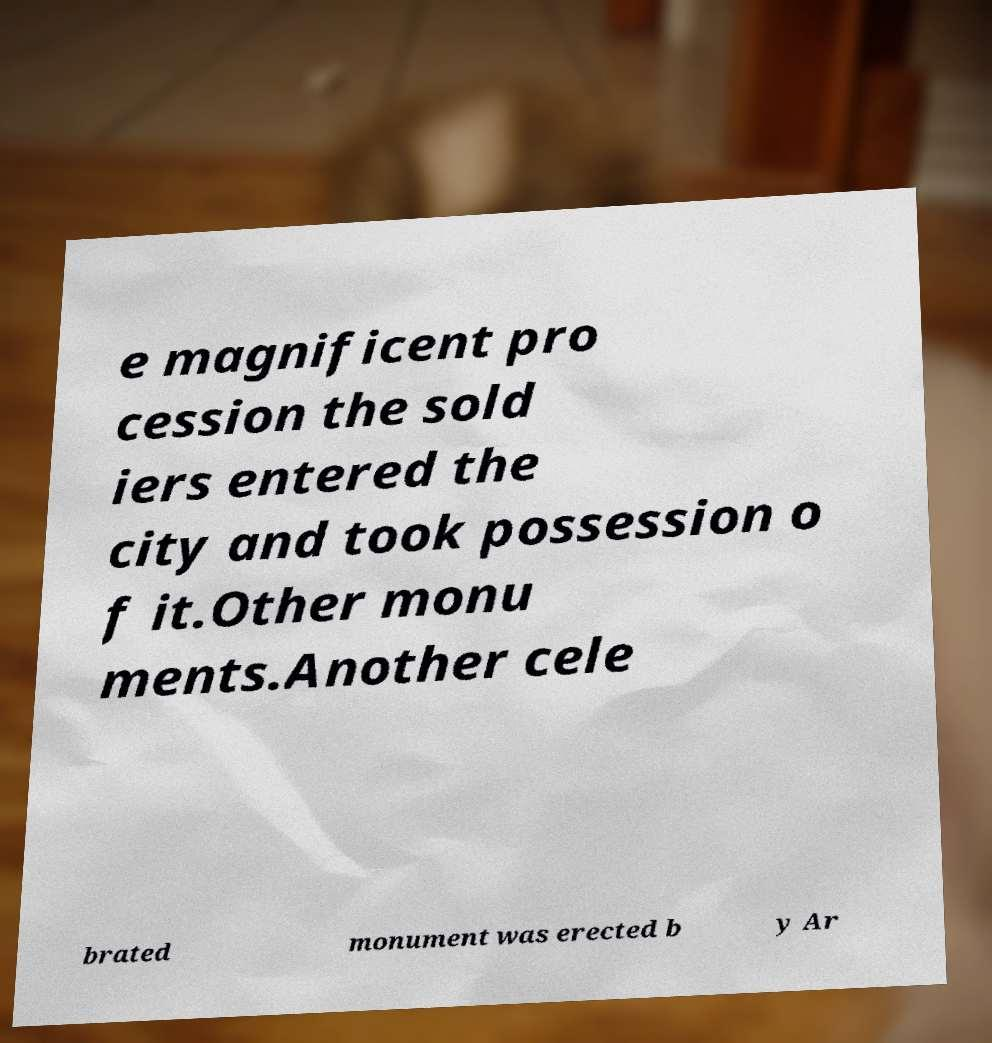For documentation purposes, I need the text within this image transcribed. Could you provide that? e magnificent pro cession the sold iers entered the city and took possession o f it.Other monu ments.Another cele brated monument was erected b y Ar 